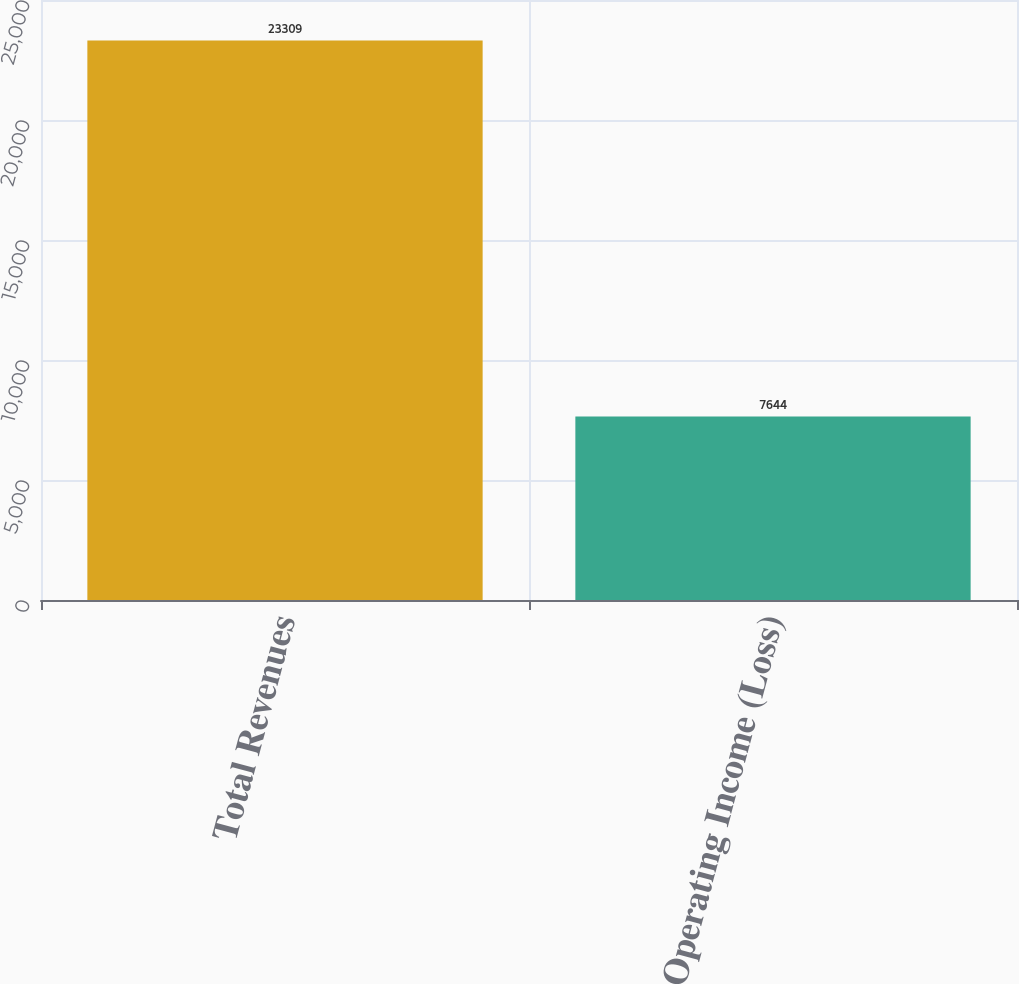Convert chart to OTSL. <chart><loc_0><loc_0><loc_500><loc_500><bar_chart><fcel>Total Revenues<fcel>Operating Income (Loss)<nl><fcel>23309<fcel>7644<nl></chart> 